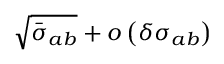<formula> <loc_0><loc_0><loc_500><loc_500>\sqrt { \bar { \sigma } _ { a b } } + o \left ( \delta \sigma _ { a b } \right )</formula> 